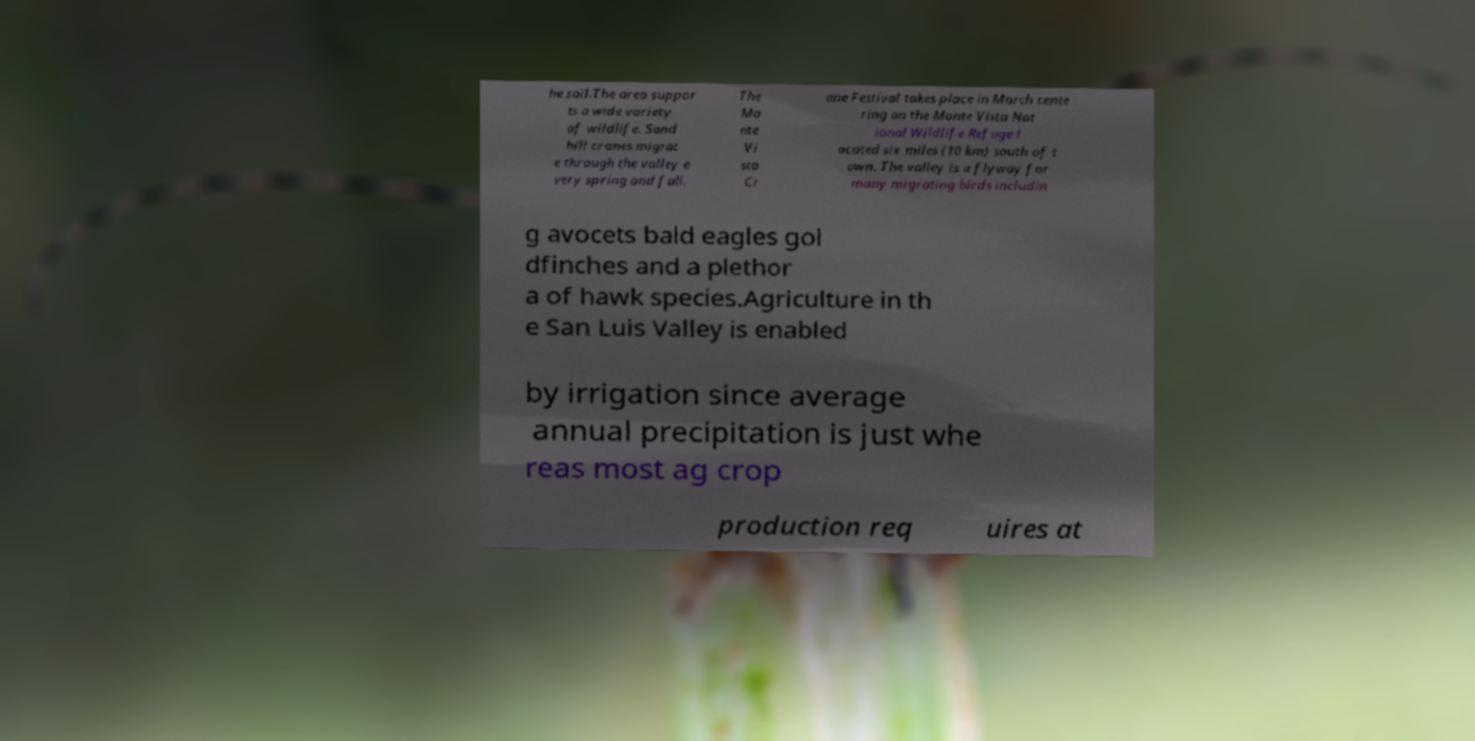Can you read and provide the text displayed in the image?This photo seems to have some interesting text. Can you extract and type it out for me? he soil.The area suppor ts a wide variety of wildlife. Sand hill cranes migrat e through the valley e very spring and fall. The Mo nte Vi sta Cr ane Festival takes place in March cente ring on the Monte Vista Nat ional Wildlife Refuge l ocated six miles (10 km) south of t own. The valley is a flyway for many migrating birds includin g avocets bald eagles gol dfinches and a plethor a of hawk species.Agriculture in th e San Luis Valley is enabled by irrigation since average annual precipitation is just whe reas most ag crop production req uires at 